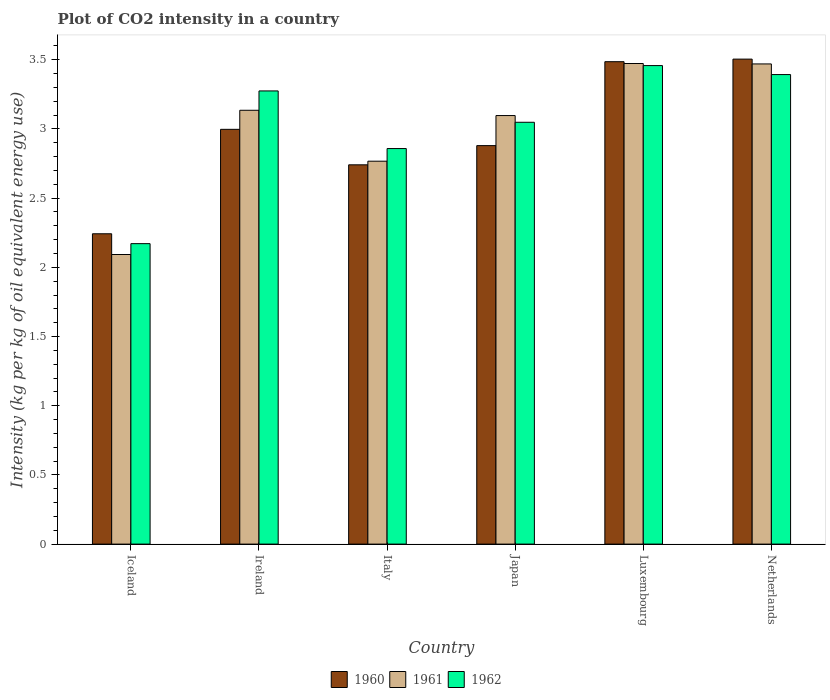How many different coloured bars are there?
Your response must be concise. 3. How many groups of bars are there?
Your answer should be compact. 6. Are the number of bars per tick equal to the number of legend labels?
Give a very brief answer. Yes. Are the number of bars on each tick of the X-axis equal?
Your response must be concise. Yes. What is the label of the 2nd group of bars from the left?
Keep it short and to the point. Ireland. In how many cases, is the number of bars for a given country not equal to the number of legend labels?
Ensure brevity in your answer.  0. What is the CO2 intensity in in 1962 in Italy?
Keep it short and to the point. 2.86. Across all countries, what is the maximum CO2 intensity in in 1961?
Give a very brief answer. 3.47. Across all countries, what is the minimum CO2 intensity in in 1962?
Your response must be concise. 2.17. In which country was the CO2 intensity in in 1962 maximum?
Your response must be concise. Luxembourg. In which country was the CO2 intensity in in 1962 minimum?
Your answer should be compact. Iceland. What is the total CO2 intensity in in 1962 in the graph?
Offer a very short reply. 18.2. What is the difference between the CO2 intensity in in 1962 in Iceland and that in Italy?
Your response must be concise. -0.69. What is the difference between the CO2 intensity in in 1962 in Japan and the CO2 intensity in in 1961 in Iceland?
Provide a succinct answer. 0.96. What is the average CO2 intensity in in 1961 per country?
Ensure brevity in your answer.  3.01. What is the difference between the CO2 intensity in of/in 1960 and CO2 intensity in of/in 1961 in Netherlands?
Offer a terse response. 0.03. What is the ratio of the CO2 intensity in in 1962 in Iceland to that in Luxembourg?
Your answer should be very brief. 0.63. Is the CO2 intensity in in 1962 in Ireland less than that in Italy?
Give a very brief answer. No. What is the difference between the highest and the second highest CO2 intensity in in 1960?
Offer a very short reply. 0.49. What is the difference between the highest and the lowest CO2 intensity in in 1960?
Offer a very short reply. 1.26. In how many countries, is the CO2 intensity in in 1961 greater than the average CO2 intensity in in 1961 taken over all countries?
Your answer should be compact. 4. Is the sum of the CO2 intensity in in 1961 in Italy and Luxembourg greater than the maximum CO2 intensity in in 1960 across all countries?
Make the answer very short. Yes. What does the 2nd bar from the right in Netherlands represents?
Give a very brief answer. 1961. Is it the case that in every country, the sum of the CO2 intensity in in 1960 and CO2 intensity in in 1962 is greater than the CO2 intensity in in 1961?
Offer a very short reply. Yes. Are all the bars in the graph horizontal?
Provide a short and direct response. No. Does the graph contain grids?
Your answer should be compact. No. Where does the legend appear in the graph?
Your answer should be very brief. Bottom center. How are the legend labels stacked?
Provide a succinct answer. Horizontal. What is the title of the graph?
Make the answer very short. Plot of CO2 intensity in a country. What is the label or title of the X-axis?
Give a very brief answer. Country. What is the label or title of the Y-axis?
Your answer should be compact. Intensity (kg per kg of oil equivalent energy use). What is the Intensity (kg per kg of oil equivalent energy use) of 1960 in Iceland?
Provide a succinct answer. 2.24. What is the Intensity (kg per kg of oil equivalent energy use) in 1961 in Iceland?
Your answer should be very brief. 2.09. What is the Intensity (kg per kg of oil equivalent energy use) in 1962 in Iceland?
Provide a succinct answer. 2.17. What is the Intensity (kg per kg of oil equivalent energy use) in 1960 in Ireland?
Offer a terse response. 3. What is the Intensity (kg per kg of oil equivalent energy use) in 1961 in Ireland?
Provide a succinct answer. 3.14. What is the Intensity (kg per kg of oil equivalent energy use) of 1962 in Ireland?
Make the answer very short. 3.27. What is the Intensity (kg per kg of oil equivalent energy use) in 1960 in Italy?
Provide a short and direct response. 2.74. What is the Intensity (kg per kg of oil equivalent energy use) of 1961 in Italy?
Provide a short and direct response. 2.77. What is the Intensity (kg per kg of oil equivalent energy use) in 1962 in Italy?
Keep it short and to the point. 2.86. What is the Intensity (kg per kg of oil equivalent energy use) in 1960 in Japan?
Your answer should be very brief. 2.88. What is the Intensity (kg per kg of oil equivalent energy use) in 1961 in Japan?
Your answer should be compact. 3.1. What is the Intensity (kg per kg of oil equivalent energy use) of 1962 in Japan?
Give a very brief answer. 3.05. What is the Intensity (kg per kg of oil equivalent energy use) in 1960 in Luxembourg?
Ensure brevity in your answer.  3.49. What is the Intensity (kg per kg of oil equivalent energy use) of 1961 in Luxembourg?
Give a very brief answer. 3.47. What is the Intensity (kg per kg of oil equivalent energy use) of 1962 in Luxembourg?
Provide a short and direct response. 3.46. What is the Intensity (kg per kg of oil equivalent energy use) in 1960 in Netherlands?
Provide a succinct answer. 3.5. What is the Intensity (kg per kg of oil equivalent energy use) of 1961 in Netherlands?
Ensure brevity in your answer.  3.47. What is the Intensity (kg per kg of oil equivalent energy use) of 1962 in Netherlands?
Provide a succinct answer. 3.39. Across all countries, what is the maximum Intensity (kg per kg of oil equivalent energy use) of 1960?
Give a very brief answer. 3.5. Across all countries, what is the maximum Intensity (kg per kg of oil equivalent energy use) of 1961?
Offer a terse response. 3.47. Across all countries, what is the maximum Intensity (kg per kg of oil equivalent energy use) of 1962?
Your answer should be very brief. 3.46. Across all countries, what is the minimum Intensity (kg per kg of oil equivalent energy use) in 1960?
Your answer should be very brief. 2.24. Across all countries, what is the minimum Intensity (kg per kg of oil equivalent energy use) of 1961?
Your answer should be compact. 2.09. Across all countries, what is the minimum Intensity (kg per kg of oil equivalent energy use) in 1962?
Your response must be concise. 2.17. What is the total Intensity (kg per kg of oil equivalent energy use) of 1960 in the graph?
Offer a very short reply. 17.85. What is the total Intensity (kg per kg of oil equivalent energy use) of 1961 in the graph?
Your answer should be compact. 18.03. What is the total Intensity (kg per kg of oil equivalent energy use) of 1962 in the graph?
Make the answer very short. 18.2. What is the difference between the Intensity (kg per kg of oil equivalent energy use) in 1960 in Iceland and that in Ireland?
Make the answer very short. -0.75. What is the difference between the Intensity (kg per kg of oil equivalent energy use) of 1961 in Iceland and that in Ireland?
Keep it short and to the point. -1.04. What is the difference between the Intensity (kg per kg of oil equivalent energy use) in 1962 in Iceland and that in Ireland?
Keep it short and to the point. -1.1. What is the difference between the Intensity (kg per kg of oil equivalent energy use) of 1960 in Iceland and that in Italy?
Ensure brevity in your answer.  -0.5. What is the difference between the Intensity (kg per kg of oil equivalent energy use) of 1961 in Iceland and that in Italy?
Offer a terse response. -0.67. What is the difference between the Intensity (kg per kg of oil equivalent energy use) of 1962 in Iceland and that in Italy?
Your answer should be very brief. -0.69. What is the difference between the Intensity (kg per kg of oil equivalent energy use) of 1960 in Iceland and that in Japan?
Ensure brevity in your answer.  -0.64. What is the difference between the Intensity (kg per kg of oil equivalent energy use) of 1961 in Iceland and that in Japan?
Offer a very short reply. -1. What is the difference between the Intensity (kg per kg of oil equivalent energy use) of 1962 in Iceland and that in Japan?
Provide a short and direct response. -0.88. What is the difference between the Intensity (kg per kg of oil equivalent energy use) of 1960 in Iceland and that in Luxembourg?
Your response must be concise. -1.24. What is the difference between the Intensity (kg per kg of oil equivalent energy use) in 1961 in Iceland and that in Luxembourg?
Provide a short and direct response. -1.38. What is the difference between the Intensity (kg per kg of oil equivalent energy use) in 1962 in Iceland and that in Luxembourg?
Keep it short and to the point. -1.29. What is the difference between the Intensity (kg per kg of oil equivalent energy use) of 1960 in Iceland and that in Netherlands?
Keep it short and to the point. -1.26. What is the difference between the Intensity (kg per kg of oil equivalent energy use) of 1961 in Iceland and that in Netherlands?
Keep it short and to the point. -1.38. What is the difference between the Intensity (kg per kg of oil equivalent energy use) in 1962 in Iceland and that in Netherlands?
Your answer should be very brief. -1.22. What is the difference between the Intensity (kg per kg of oil equivalent energy use) in 1960 in Ireland and that in Italy?
Your response must be concise. 0.26. What is the difference between the Intensity (kg per kg of oil equivalent energy use) in 1961 in Ireland and that in Italy?
Give a very brief answer. 0.37. What is the difference between the Intensity (kg per kg of oil equivalent energy use) of 1962 in Ireland and that in Italy?
Ensure brevity in your answer.  0.42. What is the difference between the Intensity (kg per kg of oil equivalent energy use) of 1960 in Ireland and that in Japan?
Make the answer very short. 0.12. What is the difference between the Intensity (kg per kg of oil equivalent energy use) of 1961 in Ireland and that in Japan?
Keep it short and to the point. 0.04. What is the difference between the Intensity (kg per kg of oil equivalent energy use) in 1962 in Ireland and that in Japan?
Give a very brief answer. 0.23. What is the difference between the Intensity (kg per kg of oil equivalent energy use) in 1960 in Ireland and that in Luxembourg?
Your answer should be very brief. -0.49. What is the difference between the Intensity (kg per kg of oil equivalent energy use) of 1961 in Ireland and that in Luxembourg?
Ensure brevity in your answer.  -0.34. What is the difference between the Intensity (kg per kg of oil equivalent energy use) in 1962 in Ireland and that in Luxembourg?
Provide a succinct answer. -0.18. What is the difference between the Intensity (kg per kg of oil equivalent energy use) of 1960 in Ireland and that in Netherlands?
Provide a succinct answer. -0.51. What is the difference between the Intensity (kg per kg of oil equivalent energy use) of 1961 in Ireland and that in Netherlands?
Provide a succinct answer. -0.33. What is the difference between the Intensity (kg per kg of oil equivalent energy use) in 1962 in Ireland and that in Netherlands?
Give a very brief answer. -0.12. What is the difference between the Intensity (kg per kg of oil equivalent energy use) in 1960 in Italy and that in Japan?
Give a very brief answer. -0.14. What is the difference between the Intensity (kg per kg of oil equivalent energy use) of 1961 in Italy and that in Japan?
Your answer should be very brief. -0.33. What is the difference between the Intensity (kg per kg of oil equivalent energy use) in 1962 in Italy and that in Japan?
Your answer should be very brief. -0.19. What is the difference between the Intensity (kg per kg of oil equivalent energy use) in 1960 in Italy and that in Luxembourg?
Offer a very short reply. -0.75. What is the difference between the Intensity (kg per kg of oil equivalent energy use) of 1961 in Italy and that in Luxembourg?
Your answer should be compact. -0.71. What is the difference between the Intensity (kg per kg of oil equivalent energy use) of 1962 in Italy and that in Luxembourg?
Offer a terse response. -0.6. What is the difference between the Intensity (kg per kg of oil equivalent energy use) in 1960 in Italy and that in Netherlands?
Ensure brevity in your answer.  -0.76. What is the difference between the Intensity (kg per kg of oil equivalent energy use) of 1961 in Italy and that in Netherlands?
Your answer should be compact. -0.7. What is the difference between the Intensity (kg per kg of oil equivalent energy use) of 1962 in Italy and that in Netherlands?
Make the answer very short. -0.53. What is the difference between the Intensity (kg per kg of oil equivalent energy use) in 1960 in Japan and that in Luxembourg?
Make the answer very short. -0.61. What is the difference between the Intensity (kg per kg of oil equivalent energy use) of 1961 in Japan and that in Luxembourg?
Keep it short and to the point. -0.38. What is the difference between the Intensity (kg per kg of oil equivalent energy use) of 1962 in Japan and that in Luxembourg?
Your answer should be very brief. -0.41. What is the difference between the Intensity (kg per kg of oil equivalent energy use) of 1960 in Japan and that in Netherlands?
Make the answer very short. -0.62. What is the difference between the Intensity (kg per kg of oil equivalent energy use) of 1961 in Japan and that in Netherlands?
Make the answer very short. -0.37. What is the difference between the Intensity (kg per kg of oil equivalent energy use) in 1962 in Japan and that in Netherlands?
Your answer should be very brief. -0.34. What is the difference between the Intensity (kg per kg of oil equivalent energy use) in 1960 in Luxembourg and that in Netherlands?
Your answer should be very brief. -0.02. What is the difference between the Intensity (kg per kg of oil equivalent energy use) of 1961 in Luxembourg and that in Netherlands?
Offer a terse response. 0. What is the difference between the Intensity (kg per kg of oil equivalent energy use) of 1962 in Luxembourg and that in Netherlands?
Give a very brief answer. 0.06. What is the difference between the Intensity (kg per kg of oil equivalent energy use) of 1960 in Iceland and the Intensity (kg per kg of oil equivalent energy use) of 1961 in Ireland?
Provide a short and direct response. -0.89. What is the difference between the Intensity (kg per kg of oil equivalent energy use) of 1960 in Iceland and the Intensity (kg per kg of oil equivalent energy use) of 1962 in Ireland?
Your answer should be very brief. -1.03. What is the difference between the Intensity (kg per kg of oil equivalent energy use) in 1961 in Iceland and the Intensity (kg per kg of oil equivalent energy use) in 1962 in Ireland?
Make the answer very short. -1.18. What is the difference between the Intensity (kg per kg of oil equivalent energy use) of 1960 in Iceland and the Intensity (kg per kg of oil equivalent energy use) of 1961 in Italy?
Your response must be concise. -0.52. What is the difference between the Intensity (kg per kg of oil equivalent energy use) of 1960 in Iceland and the Intensity (kg per kg of oil equivalent energy use) of 1962 in Italy?
Provide a succinct answer. -0.62. What is the difference between the Intensity (kg per kg of oil equivalent energy use) of 1961 in Iceland and the Intensity (kg per kg of oil equivalent energy use) of 1962 in Italy?
Ensure brevity in your answer.  -0.77. What is the difference between the Intensity (kg per kg of oil equivalent energy use) of 1960 in Iceland and the Intensity (kg per kg of oil equivalent energy use) of 1961 in Japan?
Offer a terse response. -0.85. What is the difference between the Intensity (kg per kg of oil equivalent energy use) of 1960 in Iceland and the Intensity (kg per kg of oil equivalent energy use) of 1962 in Japan?
Your answer should be compact. -0.81. What is the difference between the Intensity (kg per kg of oil equivalent energy use) of 1961 in Iceland and the Intensity (kg per kg of oil equivalent energy use) of 1962 in Japan?
Offer a very short reply. -0.96. What is the difference between the Intensity (kg per kg of oil equivalent energy use) in 1960 in Iceland and the Intensity (kg per kg of oil equivalent energy use) in 1961 in Luxembourg?
Make the answer very short. -1.23. What is the difference between the Intensity (kg per kg of oil equivalent energy use) in 1960 in Iceland and the Intensity (kg per kg of oil equivalent energy use) in 1962 in Luxembourg?
Your response must be concise. -1.22. What is the difference between the Intensity (kg per kg of oil equivalent energy use) in 1961 in Iceland and the Intensity (kg per kg of oil equivalent energy use) in 1962 in Luxembourg?
Your answer should be compact. -1.37. What is the difference between the Intensity (kg per kg of oil equivalent energy use) of 1960 in Iceland and the Intensity (kg per kg of oil equivalent energy use) of 1961 in Netherlands?
Offer a terse response. -1.23. What is the difference between the Intensity (kg per kg of oil equivalent energy use) in 1960 in Iceland and the Intensity (kg per kg of oil equivalent energy use) in 1962 in Netherlands?
Ensure brevity in your answer.  -1.15. What is the difference between the Intensity (kg per kg of oil equivalent energy use) of 1961 in Iceland and the Intensity (kg per kg of oil equivalent energy use) of 1962 in Netherlands?
Your response must be concise. -1.3. What is the difference between the Intensity (kg per kg of oil equivalent energy use) in 1960 in Ireland and the Intensity (kg per kg of oil equivalent energy use) in 1961 in Italy?
Provide a short and direct response. 0.23. What is the difference between the Intensity (kg per kg of oil equivalent energy use) in 1960 in Ireland and the Intensity (kg per kg of oil equivalent energy use) in 1962 in Italy?
Your answer should be very brief. 0.14. What is the difference between the Intensity (kg per kg of oil equivalent energy use) of 1961 in Ireland and the Intensity (kg per kg of oil equivalent energy use) of 1962 in Italy?
Your answer should be very brief. 0.28. What is the difference between the Intensity (kg per kg of oil equivalent energy use) of 1960 in Ireland and the Intensity (kg per kg of oil equivalent energy use) of 1961 in Japan?
Ensure brevity in your answer.  -0.1. What is the difference between the Intensity (kg per kg of oil equivalent energy use) in 1960 in Ireland and the Intensity (kg per kg of oil equivalent energy use) in 1962 in Japan?
Your response must be concise. -0.05. What is the difference between the Intensity (kg per kg of oil equivalent energy use) in 1961 in Ireland and the Intensity (kg per kg of oil equivalent energy use) in 1962 in Japan?
Keep it short and to the point. 0.09. What is the difference between the Intensity (kg per kg of oil equivalent energy use) in 1960 in Ireland and the Intensity (kg per kg of oil equivalent energy use) in 1961 in Luxembourg?
Give a very brief answer. -0.48. What is the difference between the Intensity (kg per kg of oil equivalent energy use) in 1960 in Ireland and the Intensity (kg per kg of oil equivalent energy use) in 1962 in Luxembourg?
Offer a terse response. -0.46. What is the difference between the Intensity (kg per kg of oil equivalent energy use) of 1961 in Ireland and the Intensity (kg per kg of oil equivalent energy use) of 1962 in Luxembourg?
Offer a very short reply. -0.32. What is the difference between the Intensity (kg per kg of oil equivalent energy use) of 1960 in Ireland and the Intensity (kg per kg of oil equivalent energy use) of 1961 in Netherlands?
Your answer should be compact. -0.47. What is the difference between the Intensity (kg per kg of oil equivalent energy use) in 1960 in Ireland and the Intensity (kg per kg of oil equivalent energy use) in 1962 in Netherlands?
Provide a succinct answer. -0.4. What is the difference between the Intensity (kg per kg of oil equivalent energy use) of 1961 in Ireland and the Intensity (kg per kg of oil equivalent energy use) of 1962 in Netherlands?
Offer a very short reply. -0.26. What is the difference between the Intensity (kg per kg of oil equivalent energy use) of 1960 in Italy and the Intensity (kg per kg of oil equivalent energy use) of 1961 in Japan?
Your answer should be compact. -0.36. What is the difference between the Intensity (kg per kg of oil equivalent energy use) in 1960 in Italy and the Intensity (kg per kg of oil equivalent energy use) in 1962 in Japan?
Your answer should be very brief. -0.31. What is the difference between the Intensity (kg per kg of oil equivalent energy use) in 1961 in Italy and the Intensity (kg per kg of oil equivalent energy use) in 1962 in Japan?
Keep it short and to the point. -0.28. What is the difference between the Intensity (kg per kg of oil equivalent energy use) in 1960 in Italy and the Intensity (kg per kg of oil equivalent energy use) in 1961 in Luxembourg?
Keep it short and to the point. -0.73. What is the difference between the Intensity (kg per kg of oil equivalent energy use) in 1960 in Italy and the Intensity (kg per kg of oil equivalent energy use) in 1962 in Luxembourg?
Your response must be concise. -0.72. What is the difference between the Intensity (kg per kg of oil equivalent energy use) in 1961 in Italy and the Intensity (kg per kg of oil equivalent energy use) in 1962 in Luxembourg?
Keep it short and to the point. -0.69. What is the difference between the Intensity (kg per kg of oil equivalent energy use) of 1960 in Italy and the Intensity (kg per kg of oil equivalent energy use) of 1961 in Netherlands?
Provide a succinct answer. -0.73. What is the difference between the Intensity (kg per kg of oil equivalent energy use) of 1960 in Italy and the Intensity (kg per kg of oil equivalent energy use) of 1962 in Netherlands?
Your response must be concise. -0.65. What is the difference between the Intensity (kg per kg of oil equivalent energy use) in 1961 in Italy and the Intensity (kg per kg of oil equivalent energy use) in 1962 in Netherlands?
Give a very brief answer. -0.63. What is the difference between the Intensity (kg per kg of oil equivalent energy use) of 1960 in Japan and the Intensity (kg per kg of oil equivalent energy use) of 1961 in Luxembourg?
Your response must be concise. -0.59. What is the difference between the Intensity (kg per kg of oil equivalent energy use) in 1960 in Japan and the Intensity (kg per kg of oil equivalent energy use) in 1962 in Luxembourg?
Offer a terse response. -0.58. What is the difference between the Intensity (kg per kg of oil equivalent energy use) in 1961 in Japan and the Intensity (kg per kg of oil equivalent energy use) in 1962 in Luxembourg?
Your answer should be very brief. -0.36. What is the difference between the Intensity (kg per kg of oil equivalent energy use) of 1960 in Japan and the Intensity (kg per kg of oil equivalent energy use) of 1961 in Netherlands?
Give a very brief answer. -0.59. What is the difference between the Intensity (kg per kg of oil equivalent energy use) in 1960 in Japan and the Intensity (kg per kg of oil equivalent energy use) in 1962 in Netherlands?
Ensure brevity in your answer.  -0.51. What is the difference between the Intensity (kg per kg of oil equivalent energy use) in 1961 in Japan and the Intensity (kg per kg of oil equivalent energy use) in 1962 in Netherlands?
Provide a short and direct response. -0.3. What is the difference between the Intensity (kg per kg of oil equivalent energy use) of 1960 in Luxembourg and the Intensity (kg per kg of oil equivalent energy use) of 1961 in Netherlands?
Ensure brevity in your answer.  0.02. What is the difference between the Intensity (kg per kg of oil equivalent energy use) of 1960 in Luxembourg and the Intensity (kg per kg of oil equivalent energy use) of 1962 in Netherlands?
Your answer should be compact. 0.09. What is the difference between the Intensity (kg per kg of oil equivalent energy use) of 1961 in Luxembourg and the Intensity (kg per kg of oil equivalent energy use) of 1962 in Netherlands?
Your response must be concise. 0.08. What is the average Intensity (kg per kg of oil equivalent energy use) of 1960 per country?
Your answer should be compact. 2.98. What is the average Intensity (kg per kg of oil equivalent energy use) in 1961 per country?
Keep it short and to the point. 3.01. What is the average Intensity (kg per kg of oil equivalent energy use) in 1962 per country?
Keep it short and to the point. 3.03. What is the difference between the Intensity (kg per kg of oil equivalent energy use) of 1960 and Intensity (kg per kg of oil equivalent energy use) of 1961 in Iceland?
Offer a very short reply. 0.15. What is the difference between the Intensity (kg per kg of oil equivalent energy use) of 1960 and Intensity (kg per kg of oil equivalent energy use) of 1962 in Iceland?
Ensure brevity in your answer.  0.07. What is the difference between the Intensity (kg per kg of oil equivalent energy use) of 1961 and Intensity (kg per kg of oil equivalent energy use) of 1962 in Iceland?
Your answer should be very brief. -0.08. What is the difference between the Intensity (kg per kg of oil equivalent energy use) in 1960 and Intensity (kg per kg of oil equivalent energy use) in 1961 in Ireland?
Provide a succinct answer. -0.14. What is the difference between the Intensity (kg per kg of oil equivalent energy use) in 1960 and Intensity (kg per kg of oil equivalent energy use) in 1962 in Ireland?
Keep it short and to the point. -0.28. What is the difference between the Intensity (kg per kg of oil equivalent energy use) of 1961 and Intensity (kg per kg of oil equivalent energy use) of 1962 in Ireland?
Your answer should be compact. -0.14. What is the difference between the Intensity (kg per kg of oil equivalent energy use) in 1960 and Intensity (kg per kg of oil equivalent energy use) in 1961 in Italy?
Give a very brief answer. -0.03. What is the difference between the Intensity (kg per kg of oil equivalent energy use) in 1960 and Intensity (kg per kg of oil equivalent energy use) in 1962 in Italy?
Provide a succinct answer. -0.12. What is the difference between the Intensity (kg per kg of oil equivalent energy use) of 1961 and Intensity (kg per kg of oil equivalent energy use) of 1962 in Italy?
Your answer should be very brief. -0.09. What is the difference between the Intensity (kg per kg of oil equivalent energy use) of 1960 and Intensity (kg per kg of oil equivalent energy use) of 1961 in Japan?
Your answer should be very brief. -0.22. What is the difference between the Intensity (kg per kg of oil equivalent energy use) of 1960 and Intensity (kg per kg of oil equivalent energy use) of 1962 in Japan?
Provide a short and direct response. -0.17. What is the difference between the Intensity (kg per kg of oil equivalent energy use) of 1961 and Intensity (kg per kg of oil equivalent energy use) of 1962 in Japan?
Your answer should be compact. 0.05. What is the difference between the Intensity (kg per kg of oil equivalent energy use) in 1960 and Intensity (kg per kg of oil equivalent energy use) in 1961 in Luxembourg?
Give a very brief answer. 0.01. What is the difference between the Intensity (kg per kg of oil equivalent energy use) in 1960 and Intensity (kg per kg of oil equivalent energy use) in 1962 in Luxembourg?
Make the answer very short. 0.03. What is the difference between the Intensity (kg per kg of oil equivalent energy use) in 1961 and Intensity (kg per kg of oil equivalent energy use) in 1962 in Luxembourg?
Ensure brevity in your answer.  0.01. What is the difference between the Intensity (kg per kg of oil equivalent energy use) of 1960 and Intensity (kg per kg of oil equivalent energy use) of 1961 in Netherlands?
Your response must be concise. 0.03. What is the difference between the Intensity (kg per kg of oil equivalent energy use) of 1960 and Intensity (kg per kg of oil equivalent energy use) of 1962 in Netherlands?
Make the answer very short. 0.11. What is the difference between the Intensity (kg per kg of oil equivalent energy use) of 1961 and Intensity (kg per kg of oil equivalent energy use) of 1962 in Netherlands?
Your answer should be very brief. 0.08. What is the ratio of the Intensity (kg per kg of oil equivalent energy use) in 1960 in Iceland to that in Ireland?
Keep it short and to the point. 0.75. What is the ratio of the Intensity (kg per kg of oil equivalent energy use) of 1961 in Iceland to that in Ireland?
Keep it short and to the point. 0.67. What is the ratio of the Intensity (kg per kg of oil equivalent energy use) in 1962 in Iceland to that in Ireland?
Offer a terse response. 0.66. What is the ratio of the Intensity (kg per kg of oil equivalent energy use) of 1960 in Iceland to that in Italy?
Provide a succinct answer. 0.82. What is the ratio of the Intensity (kg per kg of oil equivalent energy use) of 1961 in Iceland to that in Italy?
Keep it short and to the point. 0.76. What is the ratio of the Intensity (kg per kg of oil equivalent energy use) of 1962 in Iceland to that in Italy?
Provide a succinct answer. 0.76. What is the ratio of the Intensity (kg per kg of oil equivalent energy use) of 1960 in Iceland to that in Japan?
Provide a succinct answer. 0.78. What is the ratio of the Intensity (kg per kg of oil equivalent energy use) of 1961 in Iceland to that in Japan?
Provide a short and direct response. 0.68. What is the ratio of the Intensity (kg per kg of oil equivalent energy use) of 1962 in Iceland to that in Japan?
Offer a terse response. 0.71. What is the ratio of the Intensity (kg per kg of oil equivalent energy use) in 1960 in Iceland to that in Luxembourg?
Your answer should be compact. 0.64. What is the ratio of the Intensity (kg per kg of oil equivalent energy use) of 1961 in Iceland to that in Luxembourg?
Offer a very short reply. 0.6. What is the ratio of the Intensity (kg per kg of oil equivalent energy use) in 1962 in Iceland to that in Luxembourg?
Your answer should be compact. 0.63. What is the ratio of the Intensity (kg per kg of oil equivalent energy use) in 1960 in Iceland to that in Netherlands?
Your response must be concise. 0.64. What is the ratio of the Intensity (kg per kg of oil equivalent energy use) in 1961 in Iceland to that in Netherlands?
Your answer should be compact. 0.6. What is the ratio of the Intensity (kg per kg of oil equivalent energy use) of 1962 in Iceland to that in Netherlands?
Ensure brevity in your answer.  0.64. What is the ratio of the Intensity (kg per kg of oil equivalent energy use) in 1960 in Ireland to that in Italy?
Give a very brief answer. 1.09. What is the ratio of the Intensity (kg per kg of oil equivalent energy use) of 1961 in Ireland to that in Italy?
Keep it short and to the point. 1.13. What is the ratio of the Intensity (kg per kg of oil equivalent energy use) in 1962 in Ireland to that in Italy?
Keep it short and to the point. 1.15. What is the ratio of the Intensity (kg per kg of oil equivalent energy use) in 1960 in Ireland to that in Japan?
Keep it short and to the point. 1.04. What is the ratio of the Intensity (kg per kg of oil equivalent energy use) in 1961 in Ireland to that in Japan?
Provide a short and direct response. 1.01. What is the ratio of the Intensity (kg per kg of oil equivalent energy use) of 1962 in Ireland to that in Japan?
Your response must be concise. 1.07. What is the ratio of the Intensity (kg per kg of oil equivalent energy use) in 1960 in Ireland to that in Luxembourg?
Offer a terse response. 0.86. What is the ratio of the Intensity (kg per kg of oil equivalent energy use) of 1961 in Ireland to that in Luxembourg?
Provide a succinct answer. 0.9. What is the ratio of the Intensity (kg per kg of oil equivalent energy use) in 1962 in Ireland to that in Luxembourg?
Keep it short and to the point. 0.95. What is the ratio of the Intensity (kg per kg of oil equivalent energy use) of 1960 in Ireland to that in Netherlands?
Your answer should be very brief. 0.86. What is the ratio of the Intensity (kg per kg of oil equivalent energy use) of 1961 in Ireland to that in Netherlands?
Keep it short and to the point. 0.9. What is the ratio of the Intensity (kg per kg of oil equivalent energy use) in 1962 in Ireland to that in Netherlands?
Offer a terse response. 0.97. What is the ratio of the Intensity (kg per kg of oil equivalent energy use) of 1960 in Italy to that in Japan?
Provide a succinct answer. 0.95. What is the ratio of the Intensity (kg per kg of oil equivalent energy use) in 1961 in Italy to that in Japan?
Offer a terse response. 0.89. What is the ratio of the Intensity (kg per kg of oil equivalent energy use) in 1962 in Italy to that in Japan?
Give a very brief answer. 0.94. What is the ratio of the Intensity (kg per kg of oil equivalent energy use) of 1960 in Italy to that in Luxembourg?
Give a very brief answer. 0.79. What is the ratio of the Intensity (kg per kg of oil equivalent energy use) in 1961 in Italy to that in Luxembourg?
Provide a succinct answer. 0.8. What is the ratio of the Intensity (kg per kg of oil equivalent energy use) in 1962 in Italy to that in Luxembourg?
Give a very brief answer. 0.83. What is the ratio of the Intensity (kg per kg of oil equivalent energy use) of 1960 in Italy to that in Netherlands?
Your answer should be compact. 0.78. What is the ratio of the Intensity (kg per kg of oil equivalent energy use) of 1961 in Italy to that in Netherlands?
Provide a short and direct response. 0.8. What is the ratio of the Intensity (kg per kg of oil equivalent energy use) in 1962 in Italy to that in Netherlands?
Ensure brevity in your answer.  0.84. What is the ratio of the Intensity (kg per kg of oil equivalent energy use) of 1960 in Japan to that in Luxembourg?
Make the answer very short. 0.83. What is the ratio of the Intensity (kg per kg of oil equivalent energy use) in 1961 in Japan to that in Luxembourg?
Provide a succinct answer. 0.89. What is the ratio of the Intensity (kg per kg of oil equivalent energy use) in 1962 in Japan to that in Luxembourg?
Provide a succinct answer. 0.88. What is the ratio of the Intensity (kg per kg of oil equivalent energy use) in 1960 in Japan to that in Netherlands?
Make the answer very short. 0.82. What is the ratio of the Intensity (kg per kg of oil equivalent energy use) of 1961 in Japan to that in Netherlands?
Your answer should be compact. 0.89. What is the ratio of the Intensity (kg per kg of oil equivalent energy use) in 1962 in Japan to that in Netherlands?
Offer a very short reply. 0.9. What is the ratio of the Intensity (kg per kg of oil equivalent energy use) of 1960 in Luxembourg to that in Netherlands?
Offer a terse response. 0.99. What is the ratio of the Intensity (kg per kg of oil equivalent energy use) of 1961 in Luxembourg to that in Netherlands?
Provide a short and direct response. 1. What is the ratio of the Intensity (kg per kg of oil equivalent energy use) in 1962 in Luxembourg to that in Netherlands?
Offer a terse response. 1.02. What is the difference between the highest and the second highest Intensity (kg per kg of oil equivalent energy use) in 1960?
Your answer should be compact. 0.02. What is the difference between the highest and the second highest Intensity (kg per kg of oil equivalent energy use) of 1961?
Offer a very short reply. 0. What is the difference between the highest and the second highest Intensity (kg per kg of oil equivalent energy use) in 1962?
Make the answer very short. 0.06. What is the difference between the highest and the lowest Intensity (kg per kg of oil equivalent energy use) in 1960?
Keep it short and to the point. 1.26. What is the difference between the highest and the lowest Intensity (kg per kg of oil equivalent energy use) of 1961?
Your response must be concise. 1.38. What is the difference between the highest and the lowest Intensity (kg per kg of oil equivalent energy use) in 1962?
Provide a short and direct response. 1.29. 